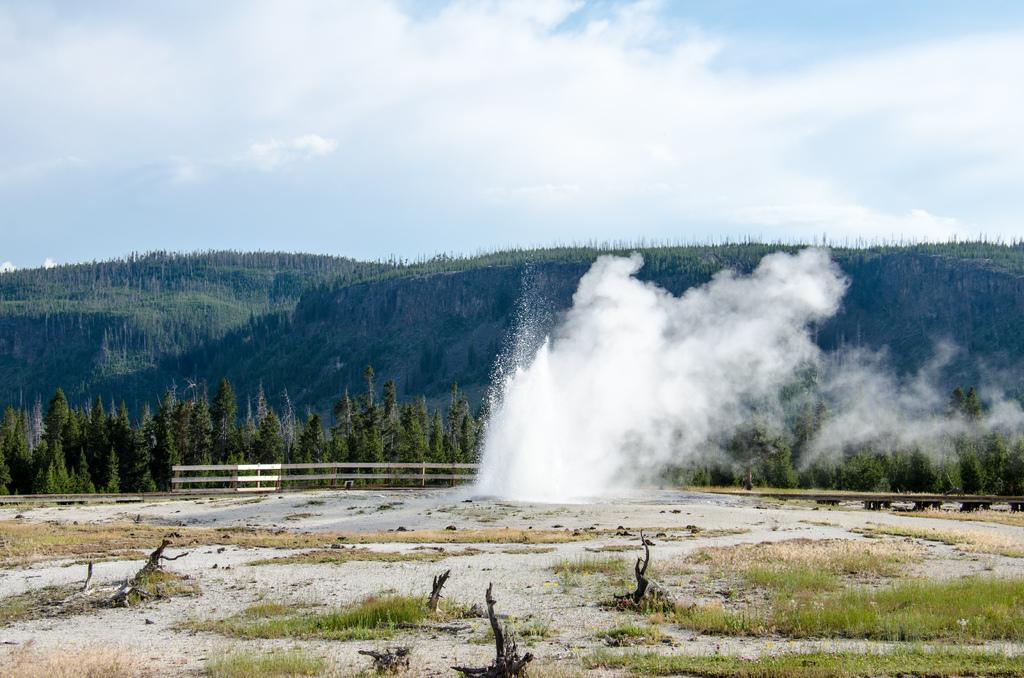Please provide a concise description of this image. In this picture we can see grass, fence, trees and in the background we can see sky with clouds. 